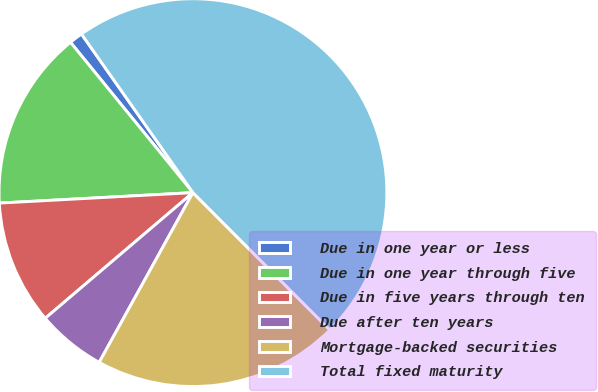<chart> <loc_0><loc_0><loc_500><loc_500><pie_chart><fcel>Due in one year or less<fcel>Due in one year through five<fcel>Due in five years through ten<fcel>Due after ten years<fcel>Mortgage-backed securities<fcel>Total fixed maturity<nl><fcel>1.13%<fcel>14.98%<fcel>10.36%<fcel>5.75%<fcel>20.51%<fcel>47.27%<nl></chart> 